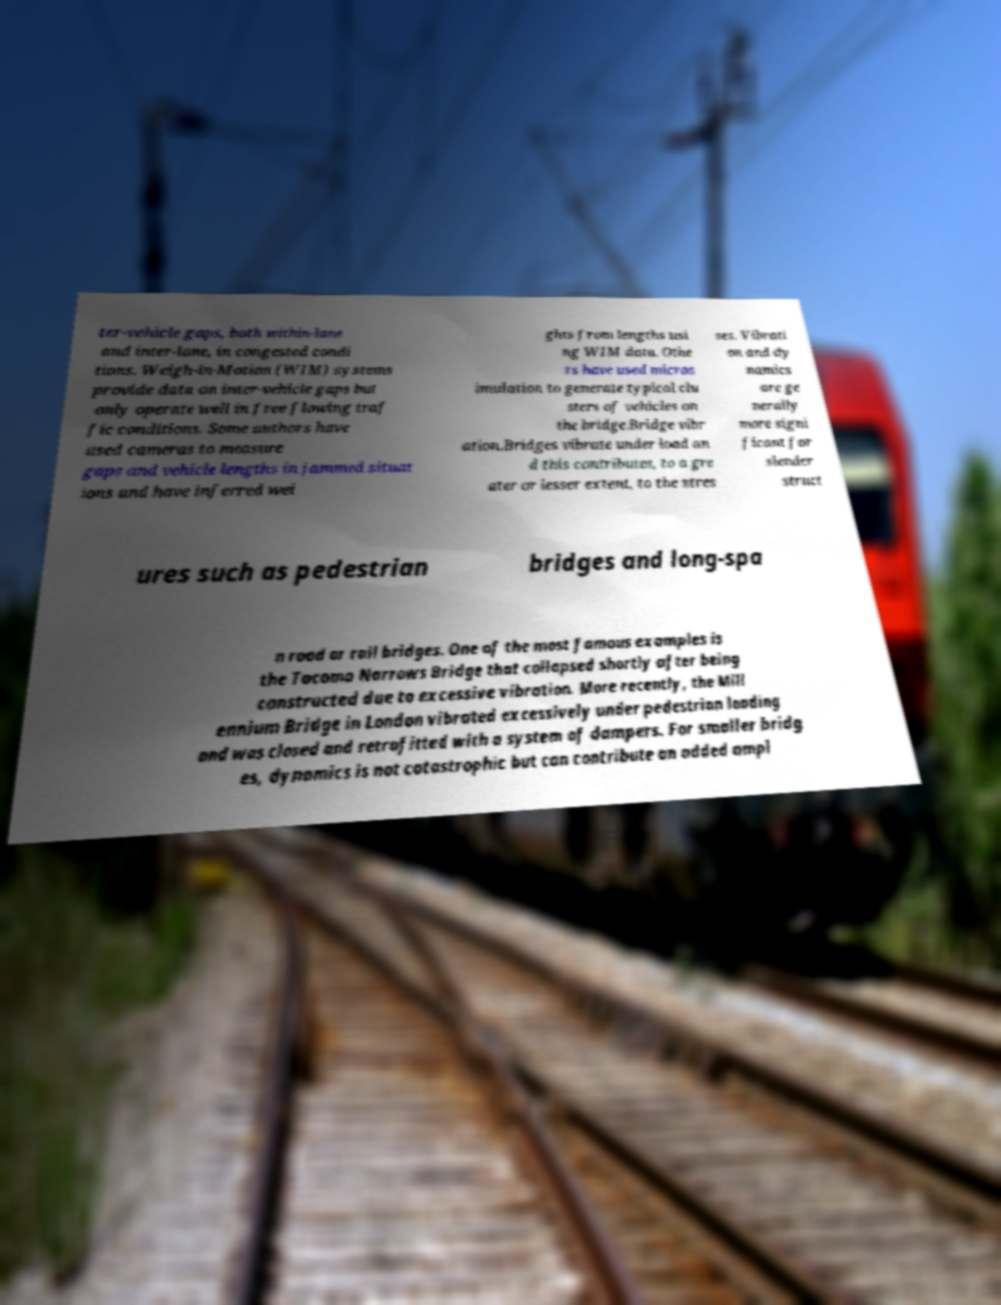Please identify and transcribe the text found in this image. ter-vehicle gaps, both within-lane and inter-lane, in congested condi tions. Weigh-in-Motion (WIM) systems provide data on inter-vehicle gaps but only operate well in free flowing traf fic conditions. Some authors have used cameras to measure gaps and vehicle lengths in jammed situat ions and have inferred wei ghts from lengths usi ng WIM data. Othe rs have used micros imulation to generate typical clu sters of vehicles on the bridge.Bridge vibr ation.Bridges vibrate under load an d this contributes, to a gre ater or lesser extent, to the stres ses. Vibrati on and dy namics are ge nerally more signi ficant for slender struct ures such as pedestrian bridges and long-spa n road or rail bridges. One of the most famous examples is the Tacoma Narrows Bridge that collapsed shortly after being constructed due to excessive vibration. More recently, the Mill ennium Bridge in London vibrated excessively under pedestrian loading and was closed and retrofitted with a system of dampers. For smaller bridg es, dynamics is not catastrophic but can contribute an added ampl 